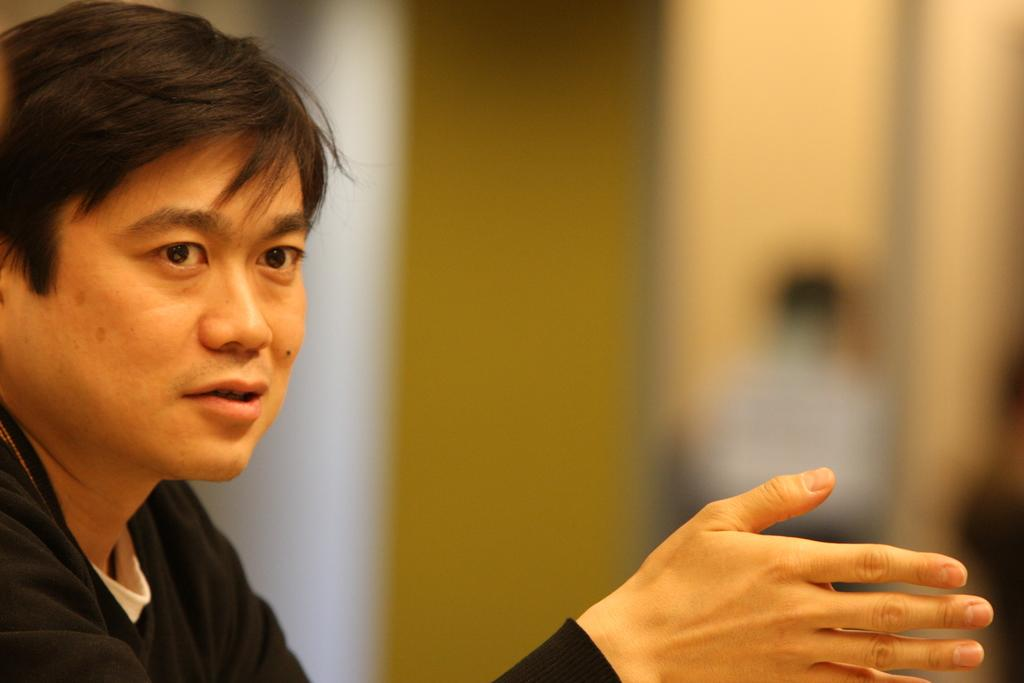Who is the main subject in the image? There is a man in the image. What is the man wearing? The man is wearing a black t-shirt. Can you describe the background of the image? The background of the image is blurred. Where is the basin located in the image? There is no basin present in the image. What type of afterthought is the man's black t-shirt? The man's black t-shirt is not an afterthought; it is a clothing item he is wearing in the image. 